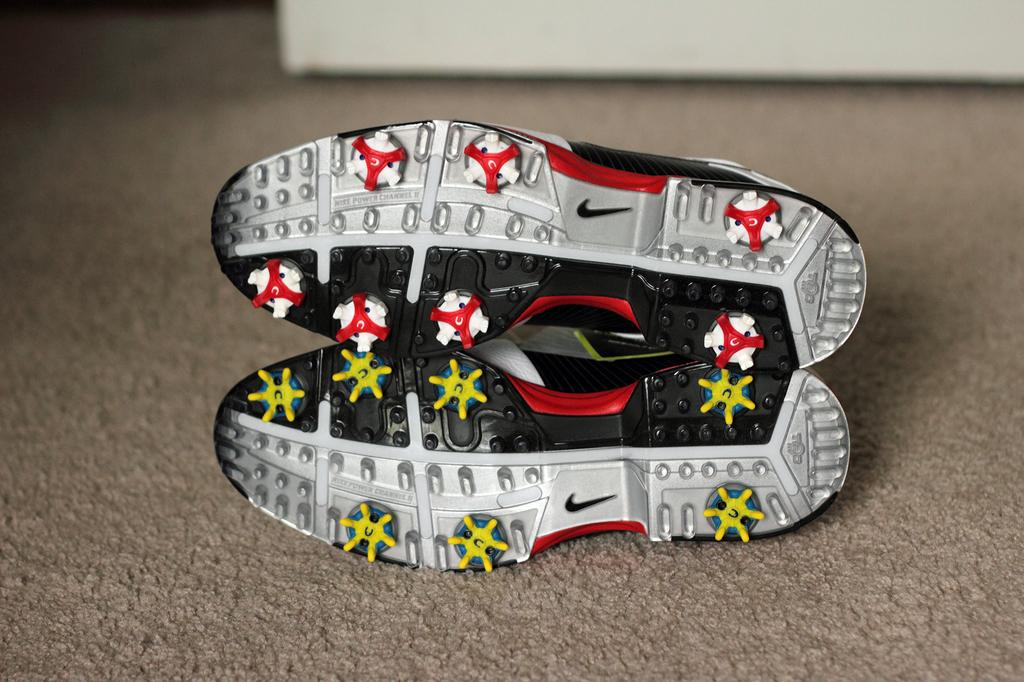What is placed on the carpet in the image? There are shoes placed on a carpet. Can you describe the object in the background of the image? Unfortunately, the provided facts do not give any details about the object in the background. What is the opinion of the mice in the image about the town? There are no mice or town present in the image, so it is not possible to determine their opinion. 